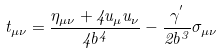<formula> <loc_0><loc_0><loc_500><loc_500>t _ { \mu \nu } = \frac { \eta _ { \mu \nu } + 4 u _ { \mu } u _ { \nu } } { 4 b ^ { 4 } } - \frac { \gamma ^ { ^ { \prime } } } { 2 b ^ { 3 } } \sigma _ { \mu \nu }</formula> 